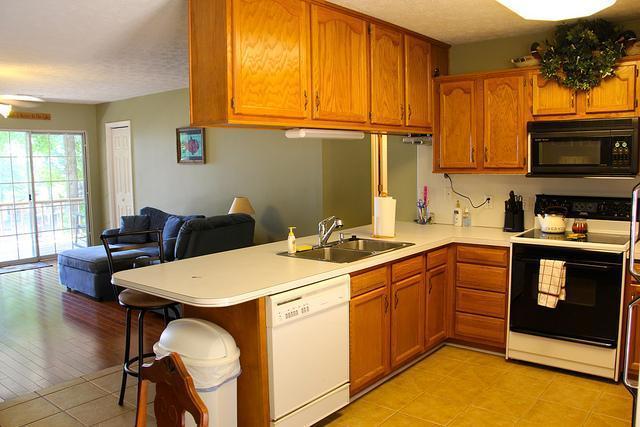How many chairs can be seen?
Give a very brief answer. 2. How many couches can be seen?
Give a very brief answer. 2. How many bears are there?
Give a very brief answer. 0. 